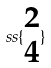<formula> <loc_0><loc_0><loc_500><loc_500>s s \{ \begin{matrix} 2 \\ 4 \end{matrix} \}</formula> 